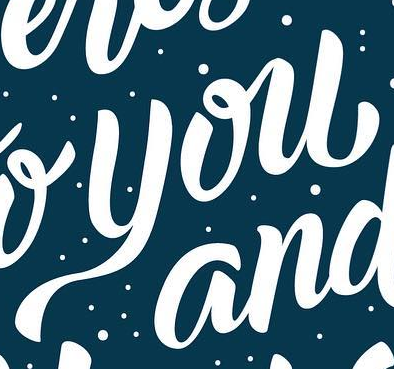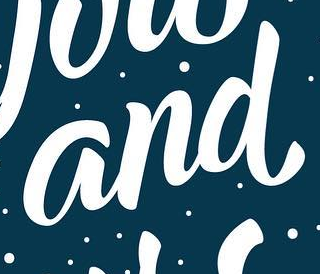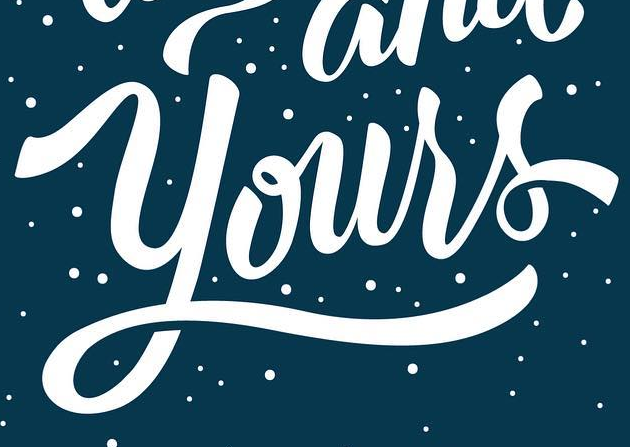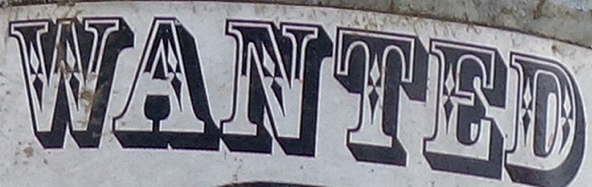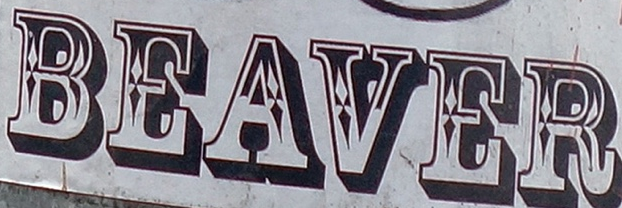What words are shown in these images in order, separated by a semicolon? you; and; Yours; WANTED; BEAVER 